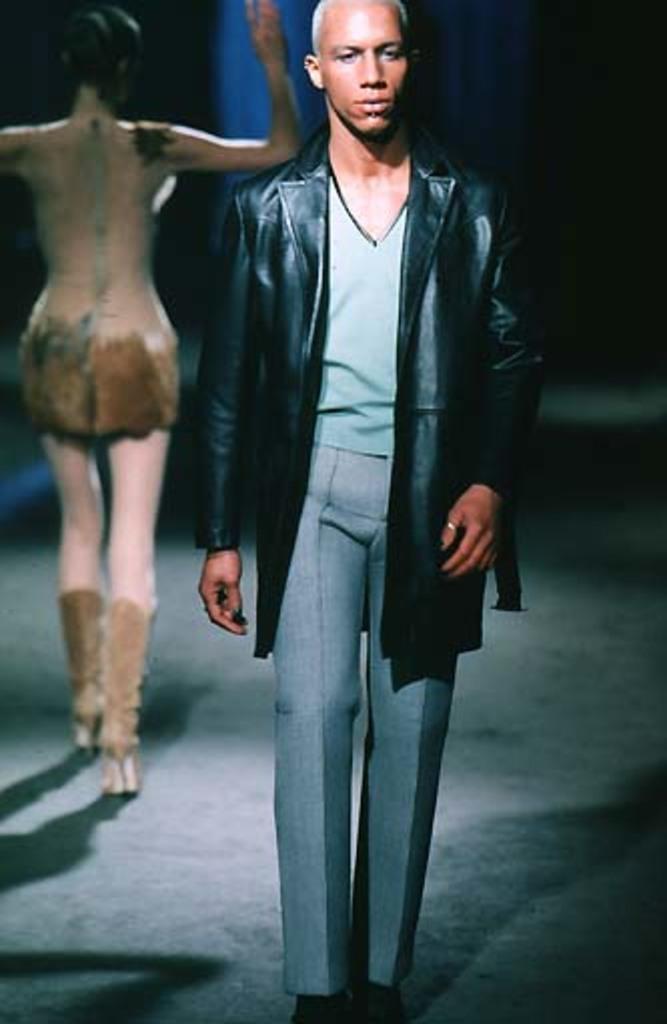Describe this image in one or two sentences. This image is taken indoors. At the bottom of the image there is a floor. In this image the background is dark. On the left side of the image a woman is walking on the floor. In the middle of the image a man is walking on the floor. He has worn a coat, a T-shirt and a pant. 